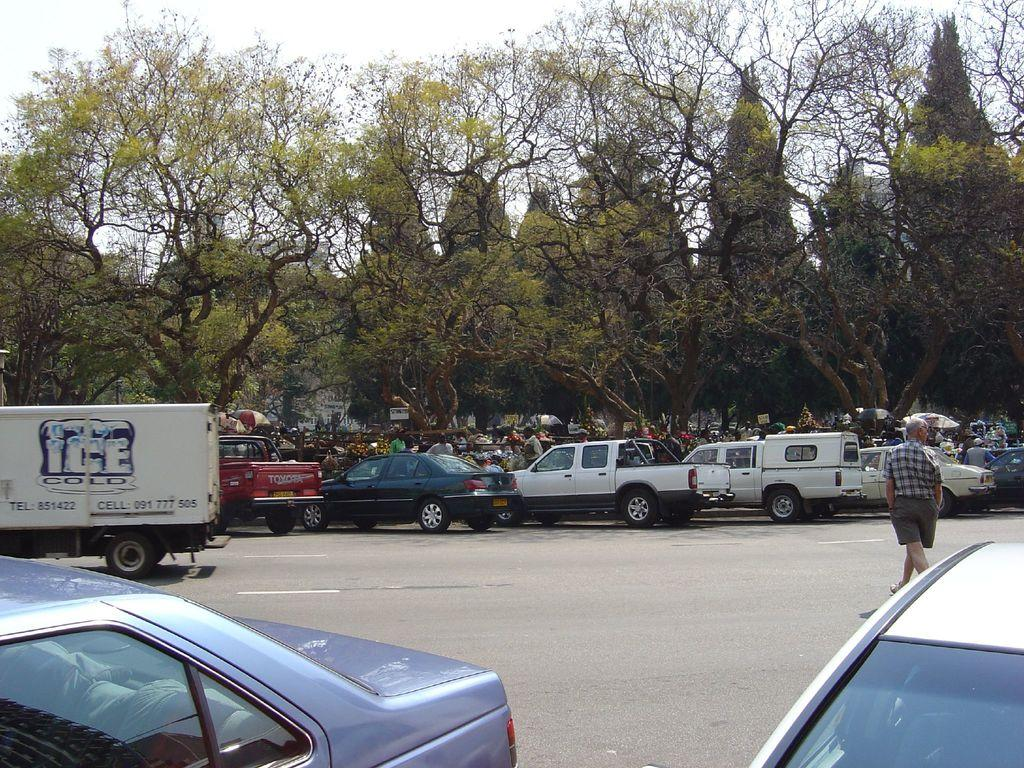What can be seen on the road in the image? There are vehicles on the road in the image. Are there any people on the road? Yes, there is a person on the road. What else can be seen in the image besides vehicles and people? There are trees visible, and there are boards visible as well. What is visible in the background of the image? The sky is visible in the background of the image. How many people are present in the image? There are few persons present in the image. What type of pets can be seen enjoying the flavor of the boards in the image? There are no pets present in the image, and the boards do not have any flavor. 